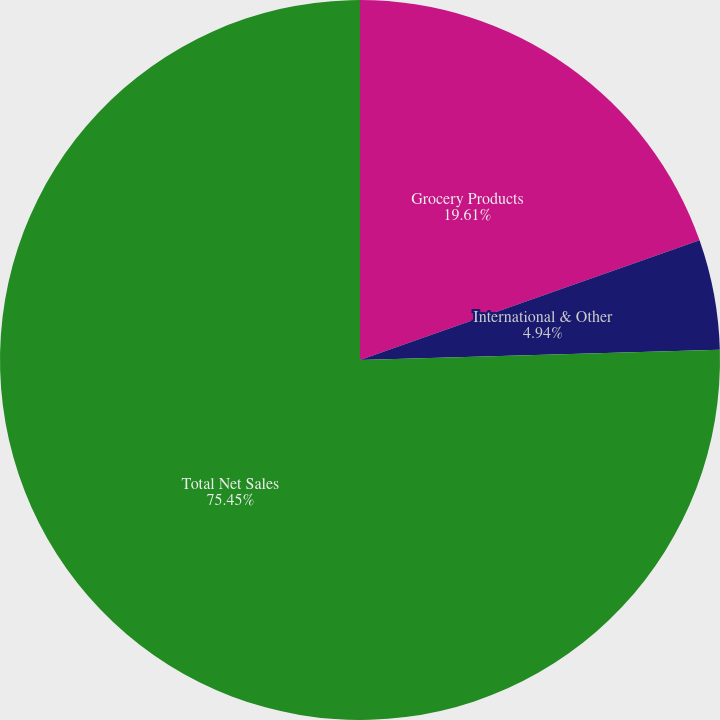Convert chart to OTSL. <chart><loc_0><loc_0><loc_500><loc_500><pie_chart><fcel>Grocery Products<fcel>International & Other<fcel>Total Net Sales<nl><fcel>19.61%<fcel>4.94%<fcel>75.46%<nl></chart> 